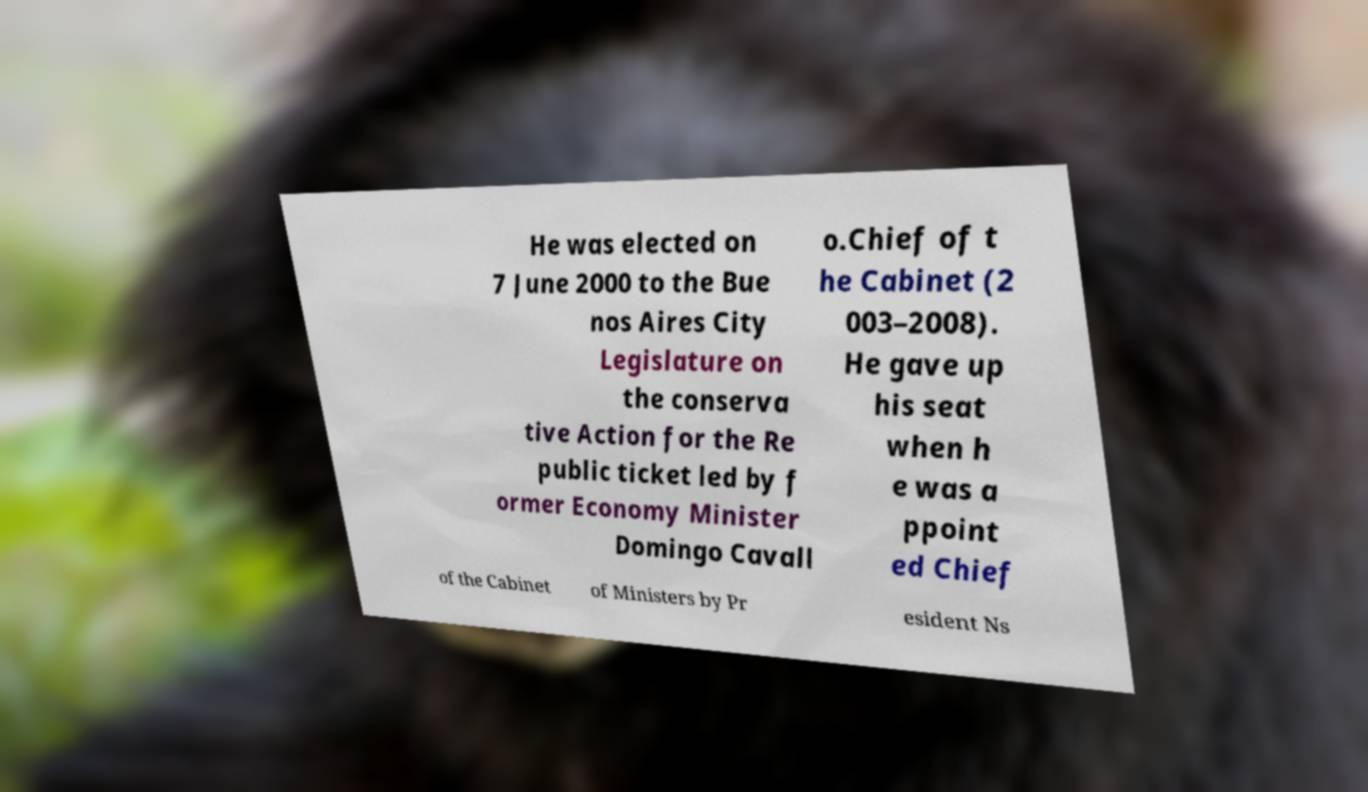Please identify and transcribe the text found in this image. He was elected on 7 June 2000 to the Bue nos Aires City Legislature on the conserva tive Action for the Re public ticket led by f ormer Economy Minister Domingo Cavall o.Chief of t he Cabinet (2 003–2008). He gave up his seat when h e was a ppoint ed Chief of the Cabinet of Ministers by Pr esident Ns 